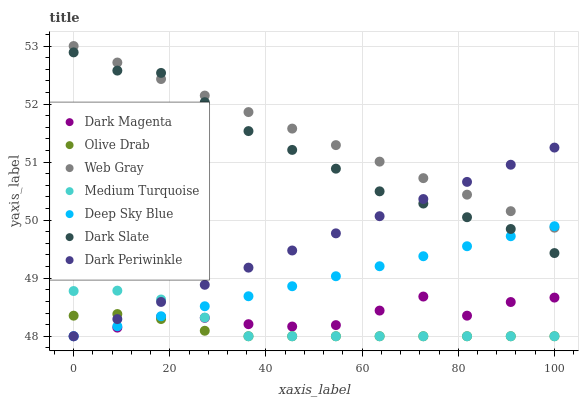Does Olive Drab have the minimum area under the curve?
Answer yes or no. Yes. Does Web Gray have the maximum area under the curve?
Answer yes or no. Yes. Does Medium Turquoise have the minimum area under the curve?
Answer yes or no. No. Does Medium Turquoise have the maximum area under the curve?
Answer yes or no. No. Is Web Gray the smoothest?
Answer yes or no. Yes. Is Dark Magenta the roughest?
Answer yes or no. Yes. Is Medium Turquoise the smoothest?
Answer yes or no. No. Is Medium Turquoise the roughest?
Answer yes or no. No. Does Medium Turquoise have the lowest value?
Answer yes or no. Yes. Does Dark Slate have the lowest value?
Answer yes or no. No. Does Web Gray have the highest value?
Answer yes or no. Yes. Does Medium Turquoise have the highest value?
Answer yes or no. No. Is Medium Turquoise less than Web Gray?
Answer yes or no. Yes. Is Dark Slate greater than Olive Drab?
Answer yes or no. Yes. Does Medium Turquoise intersect Deep Sky Blue?
Answer yes or no. Yes. Is Medium Turquoise less than Deep Sky Blue?
Answer yes or no. No. Is Medium Turquoise greater than Deep Sky Blue?
Answer yes or no. No. Does Medium Turquoise intersect Web Gray?
Answer yes or no. No. 